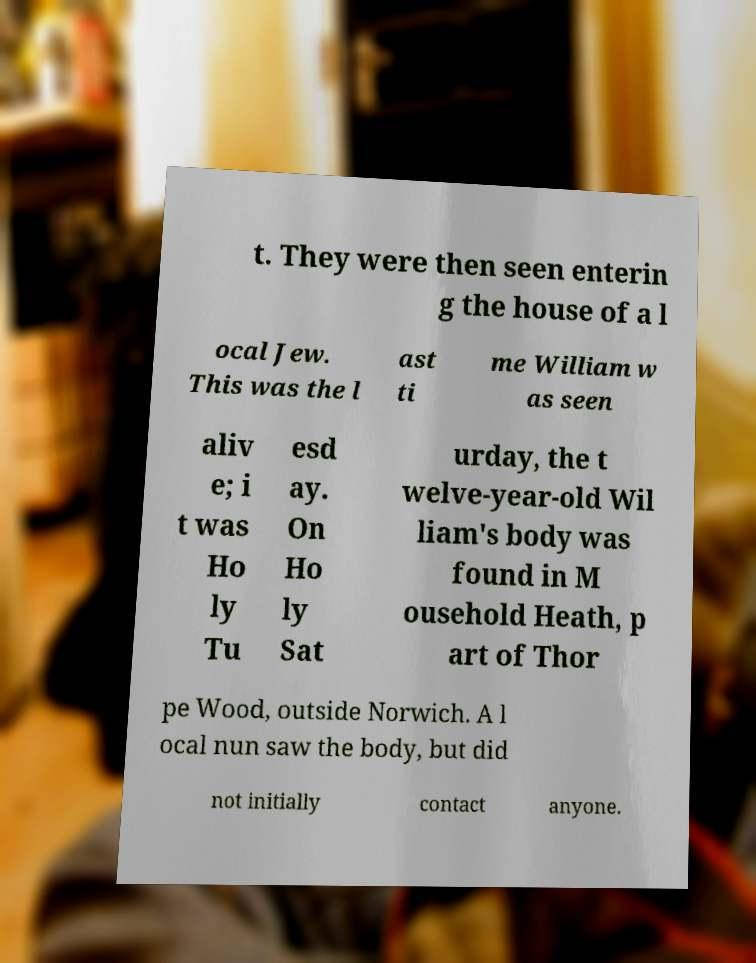For documentation purposes, I need the text within this image transcribed. Could you provide that? t. They were then seen enterin g the house of a l ocal Jew. This was the l ast ti me William w as seen aliv e; i t was Ho ly Tu esd ay. On Ho ly Sat urday, the t welve-year-old Wil liam's body was found in M ousehold Heath, p art of Thor pe Wood, outside Norwich. A l ocal nun saw the body, but did not initially contact anyone. 